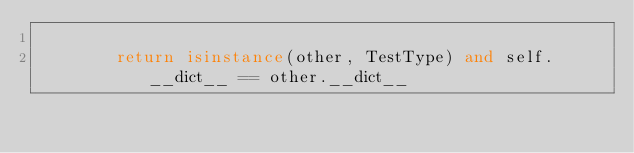Convert code to text. <code><loc_0><loc_0><loc_500><loc_500><_Python_>
        return isinstance(other, TestType) and self.__dict__ == other.__dict__
</code> 